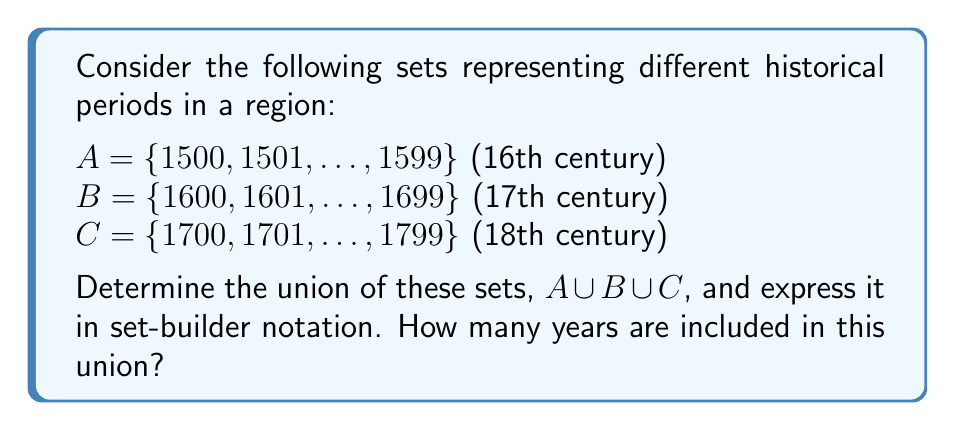Give your solution to this math problem. To solve this problem, we need to understand the concept of union in set theory and apply it to the given historical periods.

1. The union of sets A, B, and C, denoted as $A \cup B \cup C$, includes all elements that belong to at least one of these sets.

2. Let's analyze each set:
   A: Contains all years from 1500 to 1599 (16th century)
   B: Contains all years from 1600 to 1699 (17th century)
   C: Contains all years from 1700 to 1799 (18th century)

3. The union of these sets will include all years from 1500 to 1799, as there are no gaps between the centuries.

4. We can express this union in set-builder notation as:
   $A \cup B \cup C = \{x \in \mathbb{Z} \mid 1500 \leq x \leq 1799\}$

   Where $\mathbb{Z}$ represents the set of integers.

5. To determine how many years are included in this union, we can subtract the lower bound from the upper bound and add 1 (since both bounds are inclusive):

   Number of years = $1799 - 1500 + 1 = 300$

This approach allows us to concisely represent three centuries of historical events, which can be useful for organizing and presenting historical information in public talks and presentations.
Answer: $A \cup B \cup C = \{x \in \mathbb{Z} \mid 1500 \leq x \leq 1799\}$

Number of years: 300 